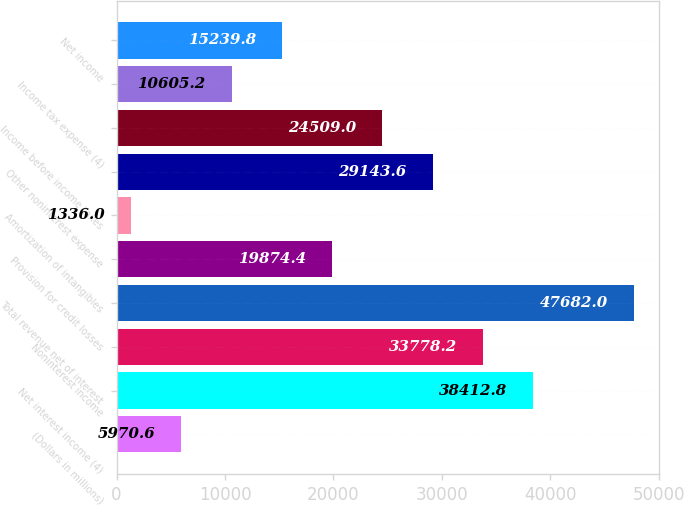Convert chart to OTSL. <chart><loc_0><loc_0><loc_500><loc_500><bar_chart><fcel>(Dollars in millions)<fcel>Net interest income (4)<fcel>Noninterest income<fcel>Total revenue net of interest<fcel>Provision for credit losses<fcel>Amortization of intangibles<fcel>Other noninterest expense<fcel>Income before income taxes<fcel>Income tax expense (4)<fcel>Net income<nl><fcel>5970.6<fcel>38412.8<fcel>33778.2<fcel>47682<fcel>19874.4<fcel>1336<fcel>29143.6<fcel>24509<fcel>10605.2<fcel>15239.8<nl></chart> 